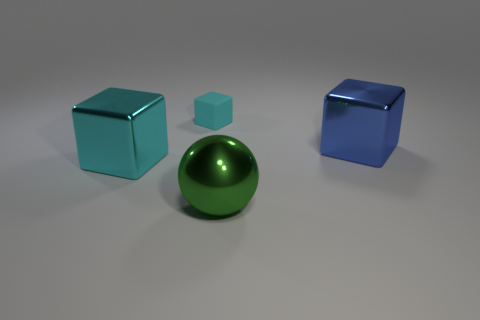What is the shape of the other object that is the same color as the matte thing?
Your answer should be very brief. Cube. How many big metallic things are in front of the large metal thing on the right side of the green ball?
Provide a succinct answer. 2. Are there any big brown rubber things that have the same shape as the large blue object?
Provide a short and direct response. No. What color is the big block that is to the right of the block in front of the large blue block?
Keep it short and to the point. Blue. Is the number of small purple balls greater than the number of spheres?
Your answer should be compact. No. How many blue things are the same size as the green sphere?
Provide a short and direct response. 1. Is the material of the large green object the same as the cube on the left side of the small cyan rubber thing?
Your answer should be very brief. Yes. Are there fewer gray rubber cylinders than green balls?
Your answer should be very brief. Yes. Is there any other thing of the same color as the metal ball?
Your answer should be very brief. No. The cyan thing that is the same material as the large blue block is what shape?
Make the answer very short. Cube. 